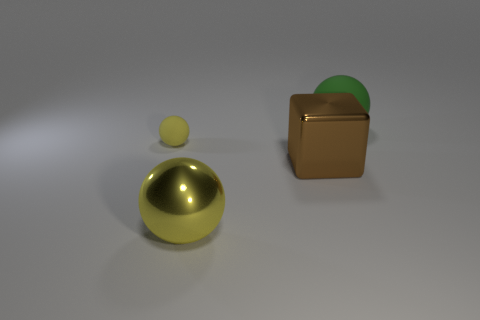Is there any other thing that is the same size as the green rubber sphere?
Give a very brief answer. Yes. There is a yellow sphere to the right of the object left of the big metal sphere; what is its material?
Your answer should be compact. Metal. Are there the same number of yellow things on the right side of the yellow metal ball and large yellow metallic spheres behind the big brown metal object?
Give a very brief answer. Yes. How many objects are large green matte objects that are right of the yellow shiny object or rubber things that are behind the tiny yellow matte ball?
Offer a very short reply. 1. What is the object that is both behind the brown metal block and on the left side of the big rubber thing made of?
Ensure brevity in your answer.  Rubber. There is a thing that is left of the large sphere left of the big thing right of the big brown metallic block; what is its size?
Keep it short and to the point. Small. Is the number of tiny yellow cylinders greater than the number of large metallic spheres?
Your answer should be very brief. No. Are the sphere in front of the metallic cube and the large brown block made of the same material?
Offer a terse response. Yes. Is the number of big metallic balls less than the number of purple metallic blocks?
Give a very brief answer. No. Is there a yellow matte object that is to the right of the rubber sphere that is to the left of the ball on the right side of the metal ball?
Provide a succinct answer. No. 